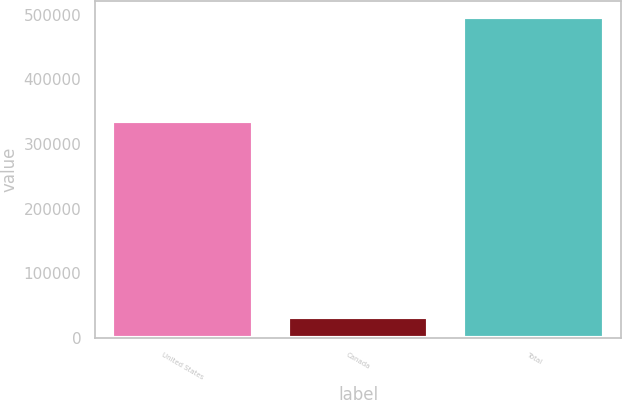<chart> <loc_0><loc_0><loc_500><loc_500><bar_chart><fcel>United States<fcel>Canada<fcel>Total<nl><fcel>335778<fcel>32160<fcel>496704<nl></chart> 